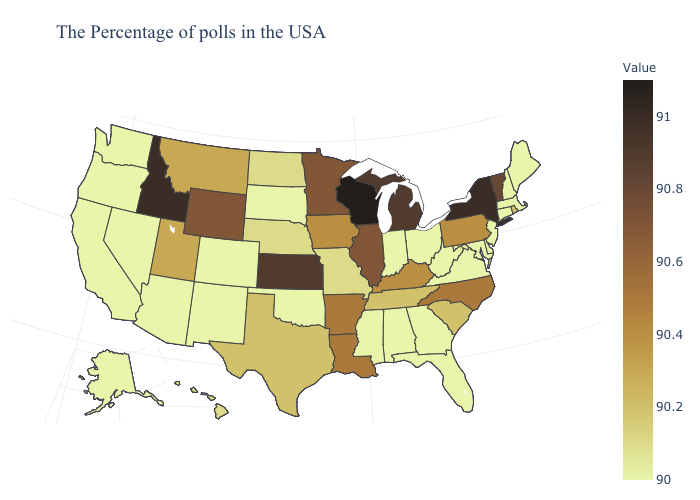Does South Carolina have a lower value than New Hampshire?
Short answer required. No. Does New Mexico have a higher value than Kansas?
Concise answer only. No. Among the states that border Georgia , does North Carolina have the highest value?
Concise answer only. Yes. Does Maryland have a higher value than Michigan?
Be succinct. No. Which states have the lowest value in the USA?
Concise answer only. Maine, Massachusetts, New Hampshire, Connecticut, New Jersey, Delaware, Maryland, Virginia, West Virginia, Ohio, Florida, Georgia, Indiana, Alabama, Mississippi, Oklahoma, South Dakota, Colorado, New Mexico, Arizona, Nevada, California, Washington, Oregon, Alaska. Among the states that border Illinois , does Iowa have the highest value?
Be succinct. No. Does Texas have the lowest value in the USA?
Give a very brief answer. No. 